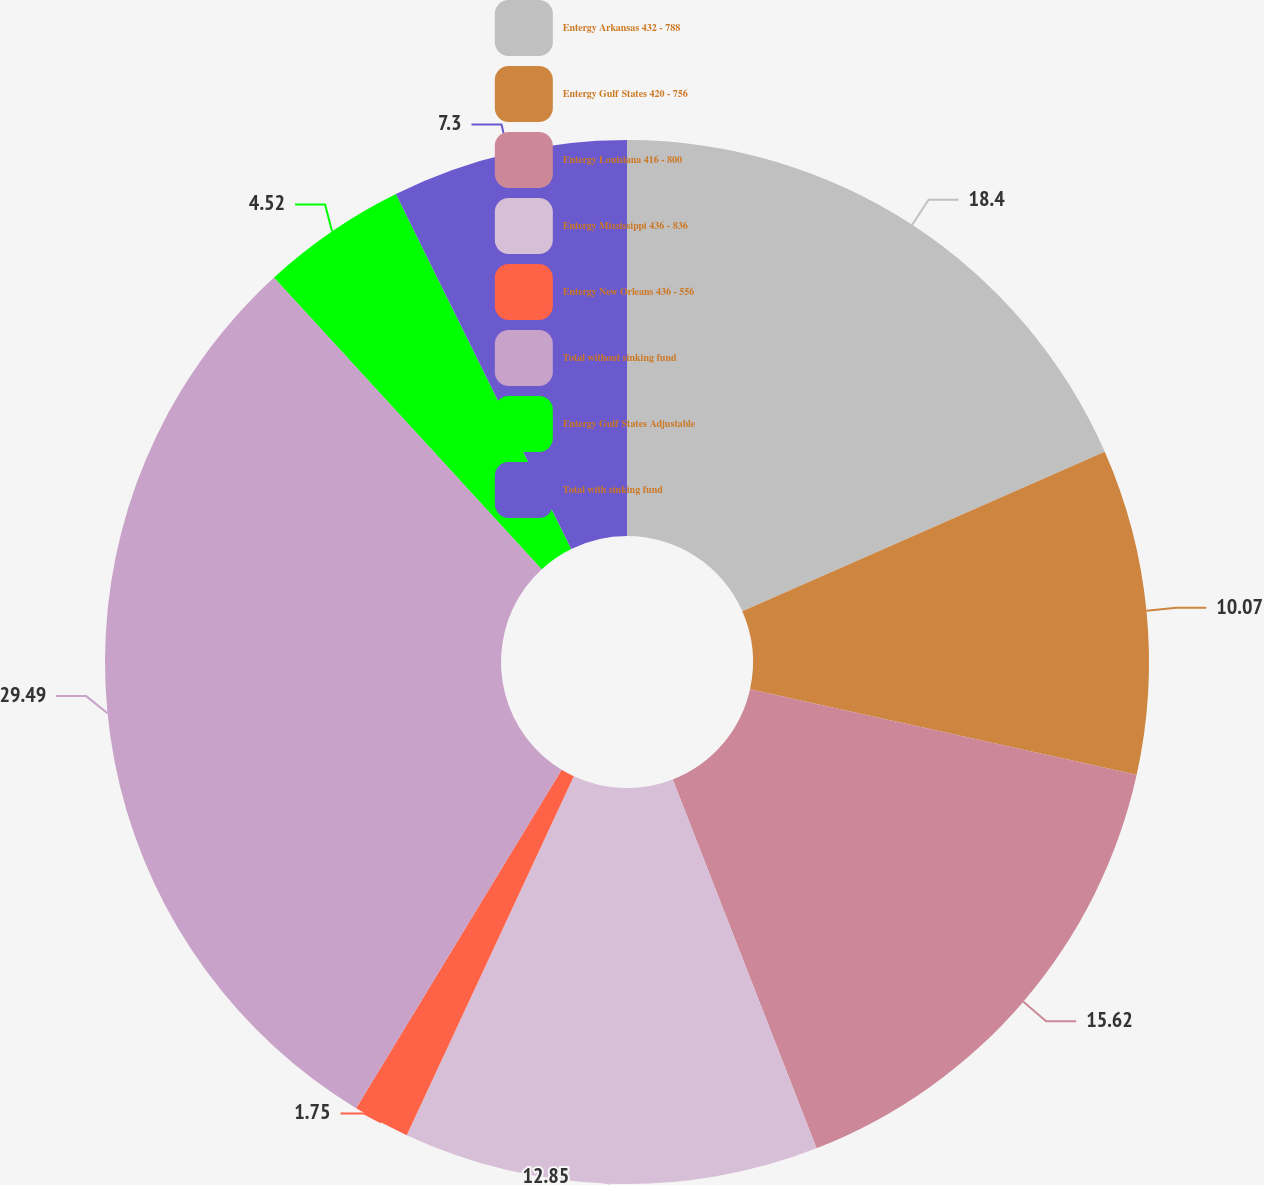Convert chart. <chart><loc_0><loc_0><loc_500><loc_500><pie_chart><fcel>Entergy Arkansas 432 - 788<fcel>Entergy Gulf States 420 - 756<fcel>Entergy Louisiana 416 - 800<fcel>Entergy Mississippi 436 - 836<fcel>Entergy New Orleans 436 - 556<fcel>Total without sinking fund<fcel>Entergy Gulf States Adjustable<fcel>Total with sinking fund<nl><fcel>18.4%<fcel>10.07%<fcel>15.62%<fcel>12.85%<fcel>1.75%<fcel>29.5%<fcel>4.52%<fcel>7.3%<nl></chart> 